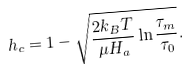Convert formula to latex. <formula><loc_0><loc_0><loc_500><loc_500>h _ { c } = 1 - \sqrt { \frac { 2 k _ { B } T } { \mu H _ { a } } \ln \frac { \tau _ { m } } { \tau _ { 0 } } } .</formula> 